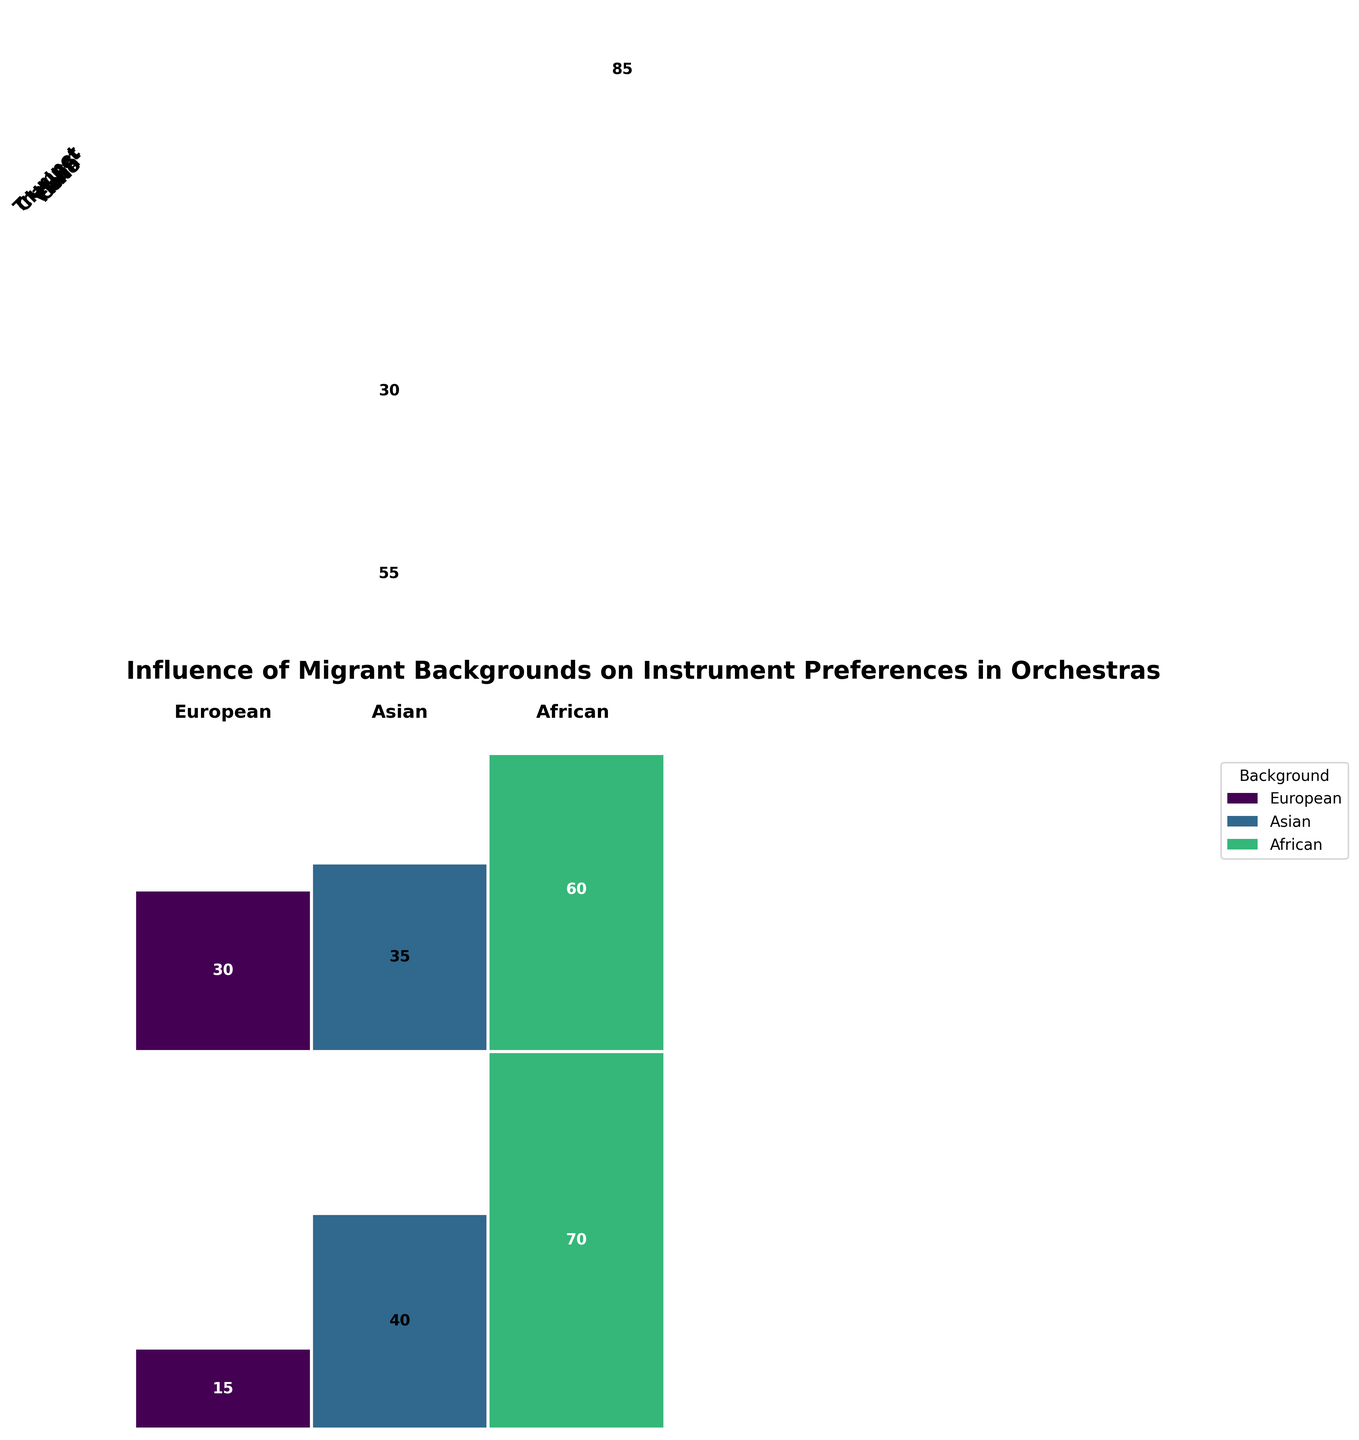How many total violinists are there from an Asian background? To find this, look at the section of the mosaic plot that corresponds to the "Violin" row and the "Asian" column. The count value inside the box should be 85.
Answer: 85 What is the background composition of the cello section? Sum the counts of players with different backgrounds in the cello section: European (70), Asian (40), African (15). The total is 70+40+15=125. Then, find the proportion for each background, European: 70/125, Asian: 40/125, African: 15/125.
Answer: European (56%), Asian (32%), African (12%) Which background has the highest preference for playing the flute? Compare the counts for each background in the flute section and identify the highest one: European (45), Asian (55), African (20). The highest count is 55, corresponding to Asian.
Answer: Asian Are there more trumpet players from an African background or clarinet players from a European background? Compare the counts directly from the respective sections: Trumpet African (40) and Clarinet European (60). 60 is greater than 40.
Answer: Clarinet players from European background What is the total number of orchestra members with a European background? Sum all counts for Europeans across all instruments: Violin (120), Cello (70), Flute (45), Trumpet (50), Clarinet (60). The total is 120+70+45+50+60=345.
Answer: 345 Which instrument has the least preference among African background, and what is the count? Check the African counts for each instrument and find the smallest: Violin (25), Cello (15), Flute (20), Trumpet (40), Clarinet (30). The smallest count is 15 for Cello.
Answer: Cello with a count of 15 How does the number of clarinet players from an Asian background compare to the number of cello players from the same background? Compare the counts: Clarinet Asian (35) and Cello Asian (40). Cello has more players.
Answer: Cello has more players Among violinists, which background is the least represented and by how much? Examine the counts for each background within the violin section: European (120), Asian (85), African (25). The least represented is African with 25. Compare it to the next smallest count (Asian at 85) for the difference: 85 - 25 = 60.
Answer: African, 60 less than Asian 